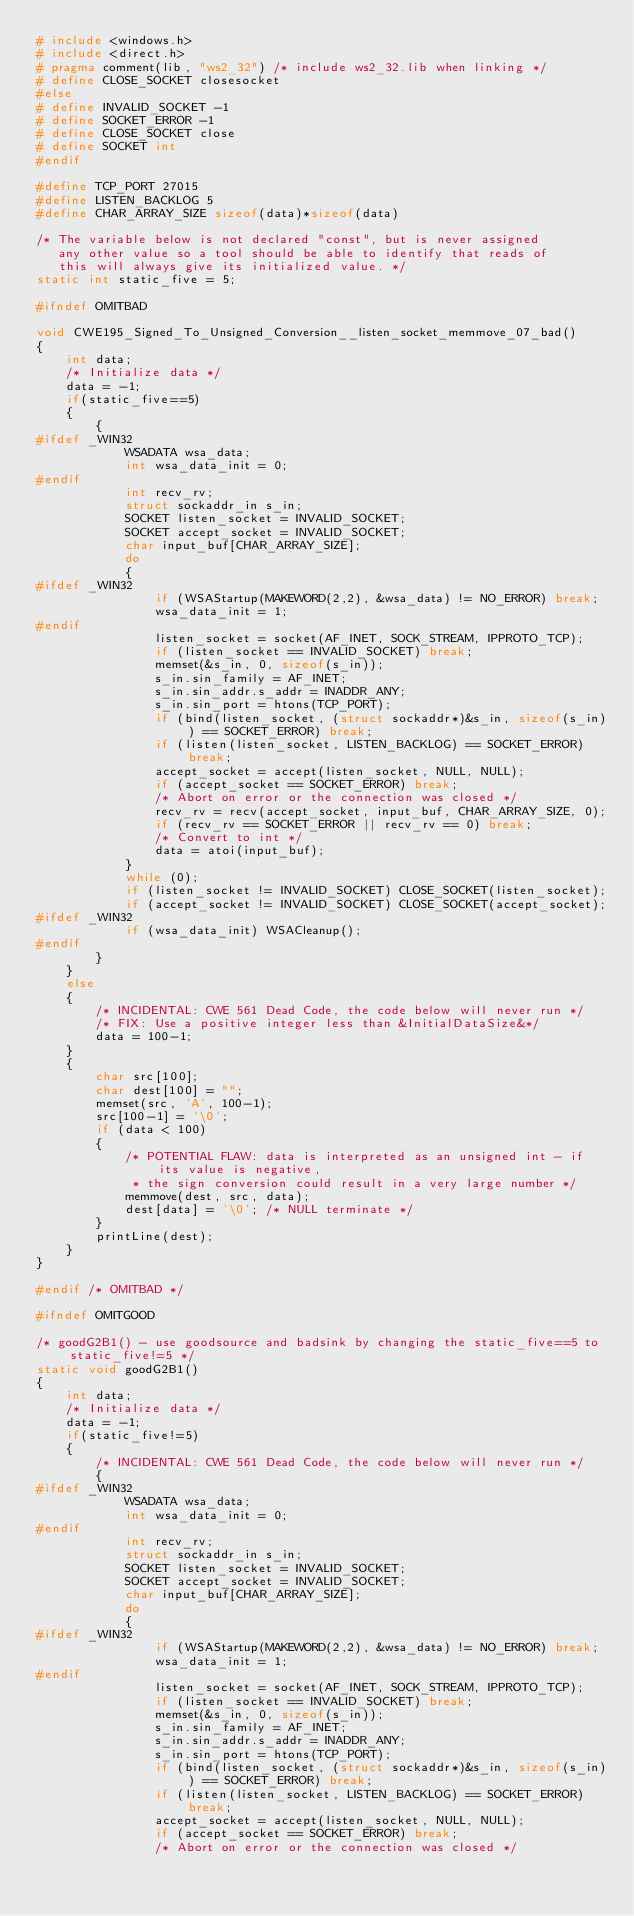Convert code to text. <code><loc_0><loc_0><loc_500><loc_500><_C_># include <windows.h>
# include <direct.h>
# pragma comment(lib, "ws2_32") /* include ws2_32.lib when linking */
# define CLOSE_SOCKET closesocket
#else
# define INVALID_SOCKET -1
# define SOCKET_ERROR -1
# define CLOSE_SOCKET close
# define SOCKET int
#endif

#define TCP_PORT 27015
#define LISTEN_BACKLOG 5
#define CHAR_ARRAY_SIZE sizeof(data)*sizeof(data)

/* The variable below is not declared "const", but is never assigned
   any other value so a tool should be able to identify that reads of
   this will always give its initialized value. */
static int static_five = 5;

#ifndef OMITBAD

void CWE195_Signed_To_Unsigned_Conversion__listen_socket_memmove_07_bad()
{
    int data;
    /* Initialize data */
    data = -1;
    if(static_five==5)
    {
        {
#ifdef _WIN32
            WSADATA wsa_data;
            int wsa_data_init = 0;
#endif
            int recv_rv;
            struct sockaddr_in s_in;
            SOCKET listen_socket = INVALID_SOCKET;
            SOCKET accept_socket = INVALID_SOCKET;
            char input_buf[CHAR_ARRAY_SIZE];
            do
            {
#ifdef _WIN32
                if (WSAStartup(MAKEWORD(2,2), &wsa_data) != NO_ERROR) break;
                wsa_data_init = 1;
#endif
                listen_socket = socket(AF_INET, SOCK_STREAM, IPPROTO_TCP);
                if (listen_socket == INVALID_SOCKET) break;
                memset(&s_in, 0, sizeof(s_in));
                s_in.sin_family = AF_INET;
                s_in.sin_addr.s_addr = INADDR_ANY;
                s_in.sin_port = htons(TCP_PORT);
                if (bind(listen_socket, (struct sockaddr*)&s_in, sizeof(s_in)) == SOCKET_ERROR) break;
                if (listen(listen_socket, LISTEN_BACKLOG) == SOCKET_ERROR) break;
                accept_socket = accept(listen_socket, NULL, NULL);
                if (accept_socket == SOCKET_ERROR) break;
                /* Abort on error or the connection was closed */
                recv_rv = recv(accept_socket, input_buf, CHAR_ARRAY_SIZE, 0);
                if (recv_rv == SOCKET_ERROR || recv_rv == 0) break;
                /* Convert to int */
                data = atoi(input_buf);
            }
            while (0);
            if (listen_socket != INVALID_SOCKET) CLOSE_SOCKET(listen_socket);
            if (accept_socket != INVALID_SOCKET) CLOSE_SOCKET(accept_socket);
#ifdef _WIN32
            if (wsa_data_init) WSACleanup();
#endif
        }
    }
    else
    {
        /* INCIDENTAL: CWE 561 Dead Code, the code below will never run */
        /* FIX: Use a positive integer less than &InitialDataSize&*/
        data = 100-1;
    }
    {
        char src[100];
        char dest[100] = "";
        memset(src, 'A', 100-1);
        src[100-1] = '\0';
        if (data < 100)
        {
            /* POTENTIAL FLAW: data is interpreted as an unsigned int - if its value is negative,
             * the sign conversion could result in a very large number */
            memmove(dest, src, data);
            dest[data] = '\0'; /* NULL terminate */
        }
        printLine(dest);
    }
}

#endif /* OMITBAD */

#ifndef OMITGOOD

/* goodG2B1() - use goodsource and badsink by changing the static_five==5 to static_five!=5 */
static void goodG2B1()
{
    int data;
    /* Initialize data */
    data = -1;
    if(static_five!=5)
    {
        /* INCIDENTAL: CWE 561 Dead Code, the code below will never run */
        {
#ifdef _WIN32
            WSADATA wsa_data;
            int wsa_data_init = 0;
#endif
            int recv_rv;
            struct sockaddr_in s_in;
            SOCKET listen_socket = INVALID_SOCKET;
            SOCKET accept_socket = INVALID_SOCKET;
            char input_buf[CHAR_ARRAY_SIZE];
            do
            {
#ifdef _WIN32
                if (WSAStartup(MAKEWORD(2,2), &wsa_data) != NO_ERROR) break;
                wsa_data_init = 1;
#endif
                listen_socket = socket(AF_INET, SOCK_STREAM, IPPROTO_TCP);
                if (listen_socket == INVALID_SOCKET) break;
                memset(&s_in, 0, sizeof(s_in));
                s_in.sin_family = AF_INET;
                s_in.sin_addr.s_addr = INADDR_ANY;
                s_in.sin_port = htons(TCP_PORT);
                if (bind(listen_socket, (struct sockaddr*)&s_in, sizeof(s_in)) == SOCKET_ERROR) break;
                if (listen(listen_socket, LISTEN_BACKLOG) == SOCKET_ERROR) break;
                accept_socket = accept(listen_socket, NULL, NULL);
                if (accept_socket == SOCKET_ERROR) break;
                /* Abort on error or the connection was closed */</code> 